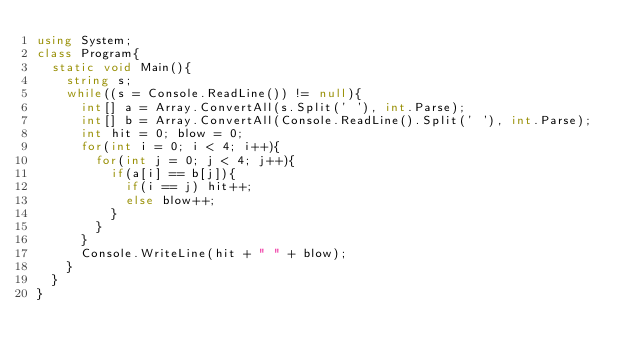Convert code to text. <code><loc_0><loc_0><loc_500><loc_500><_C#_>using System;
class Program{
	static void Main(){
		string s;
		while((s = Console.ReadLine()) != null){
			int[] a = Array.ConvertAll(s.Split(' '), int.Parse);
			int[] b = Array.ConvertAll(Console.ReadLine().Split(' '), int.Parse);
			int hit = 0; blow = 0;
			for(int i = 0; i < 4; i++){
				for(int j = 0; j < 4; j++){
					if(a[i] == b[j]){
						if(i == j) hit++;
						else blow++;
					}
				}
			}
			Console.WriteLine(hit + " " + blow);
		}
	}
}</code> 